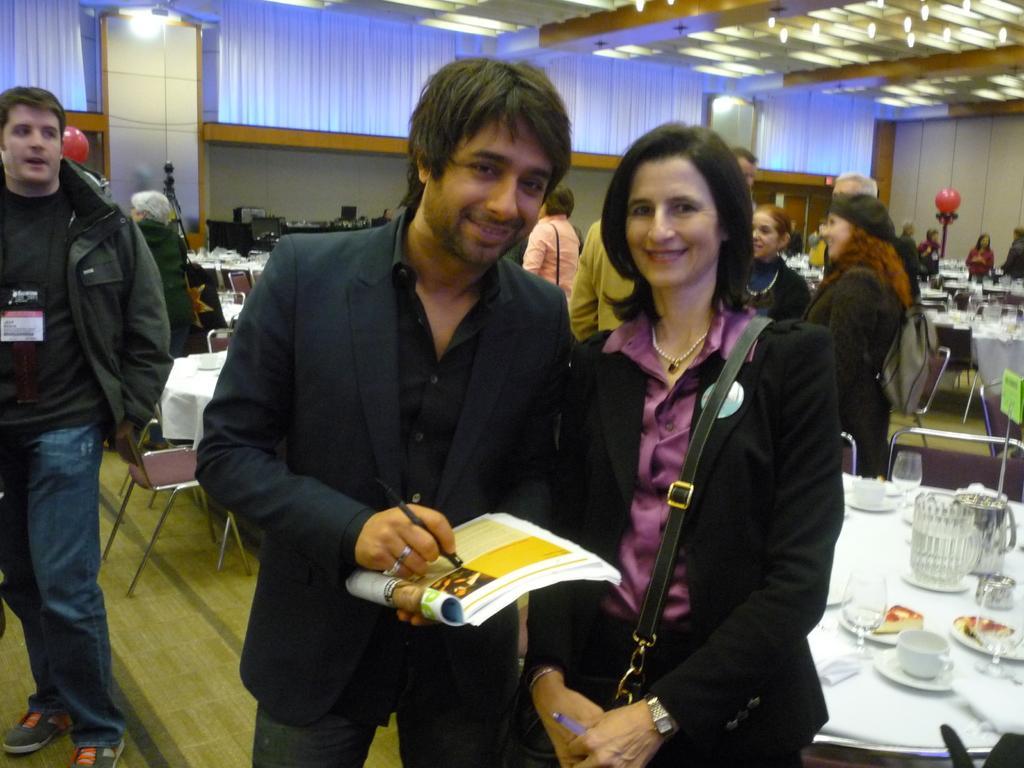How would you summarize this image in a sentence or two? In this image we can see a group of people standing. In that a man is holding a book and a pen. We can also see some glasses, cups with saucers, some food and jars which are placed on the tables. On the backside we can see some curtains, wall and a roof with some ceiling lights. 